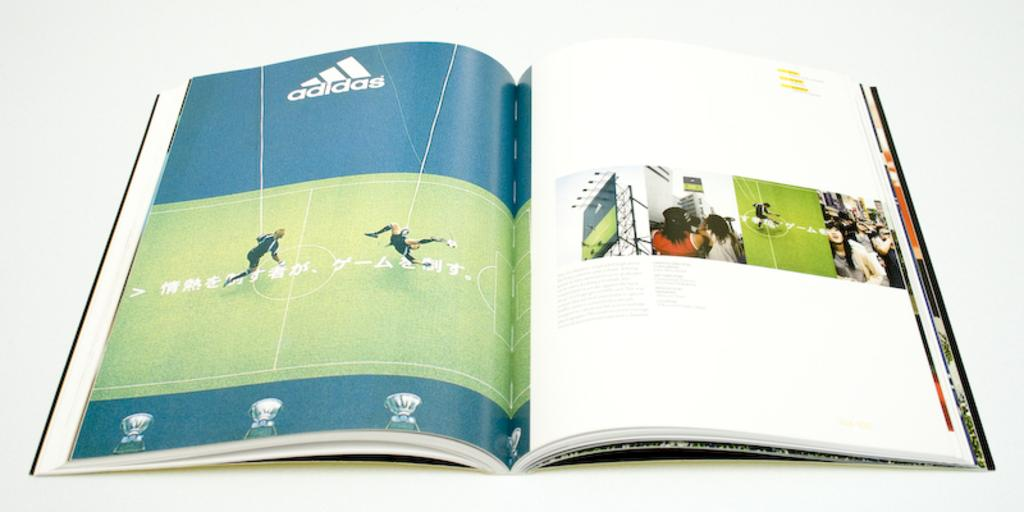<image>
Share a concise interpretation of the image provided. Open magazine with the Adidas logo below a soccer field. 